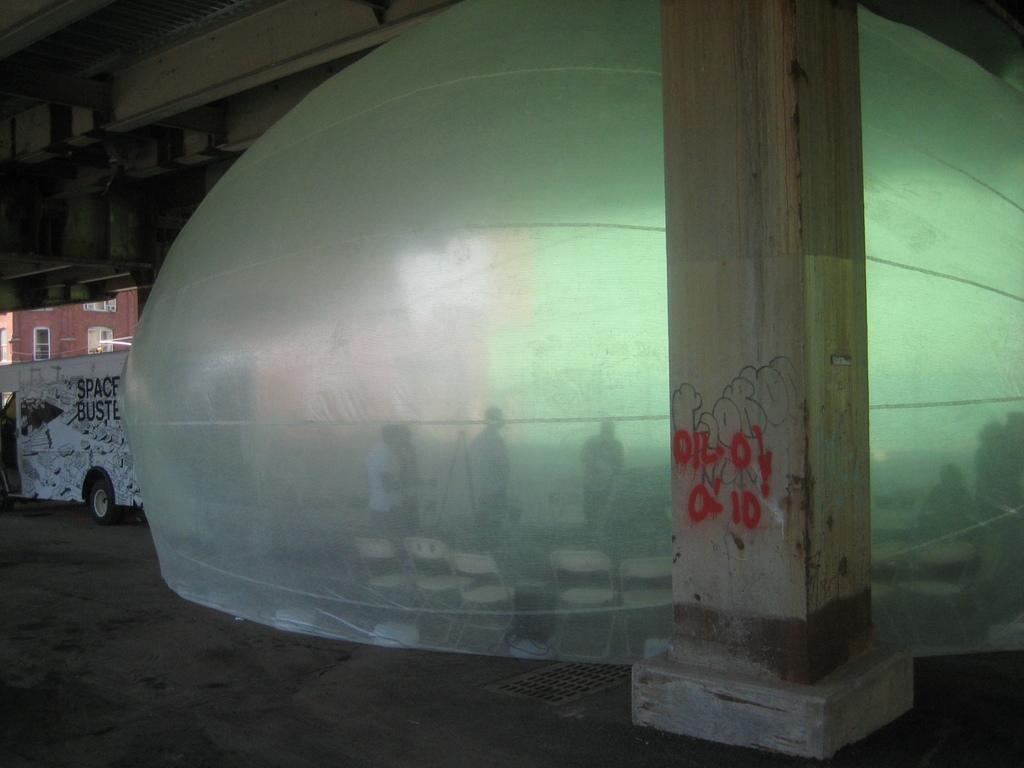What type of structure can be seen in the image? There is a pillar in the image. What is the unique feature in the image? There is a bubble tent in the image. What type of furniture is present in the image? There are chairs in the image. Are there any people in the image? Yes, there are people in the image. What can be seen on the road in the image? There is a vehicle on the road in the image. What type of building is visible in the image? There is a building in the image. What other objects can be seen in the image? There are some objects in the image. Who is the creator of the bubble tent in the image? There is no information about the creator of the bubble tent in the image. What is the size of the pillar in the image? The size of the pillar cannot be determined from the image alone. 